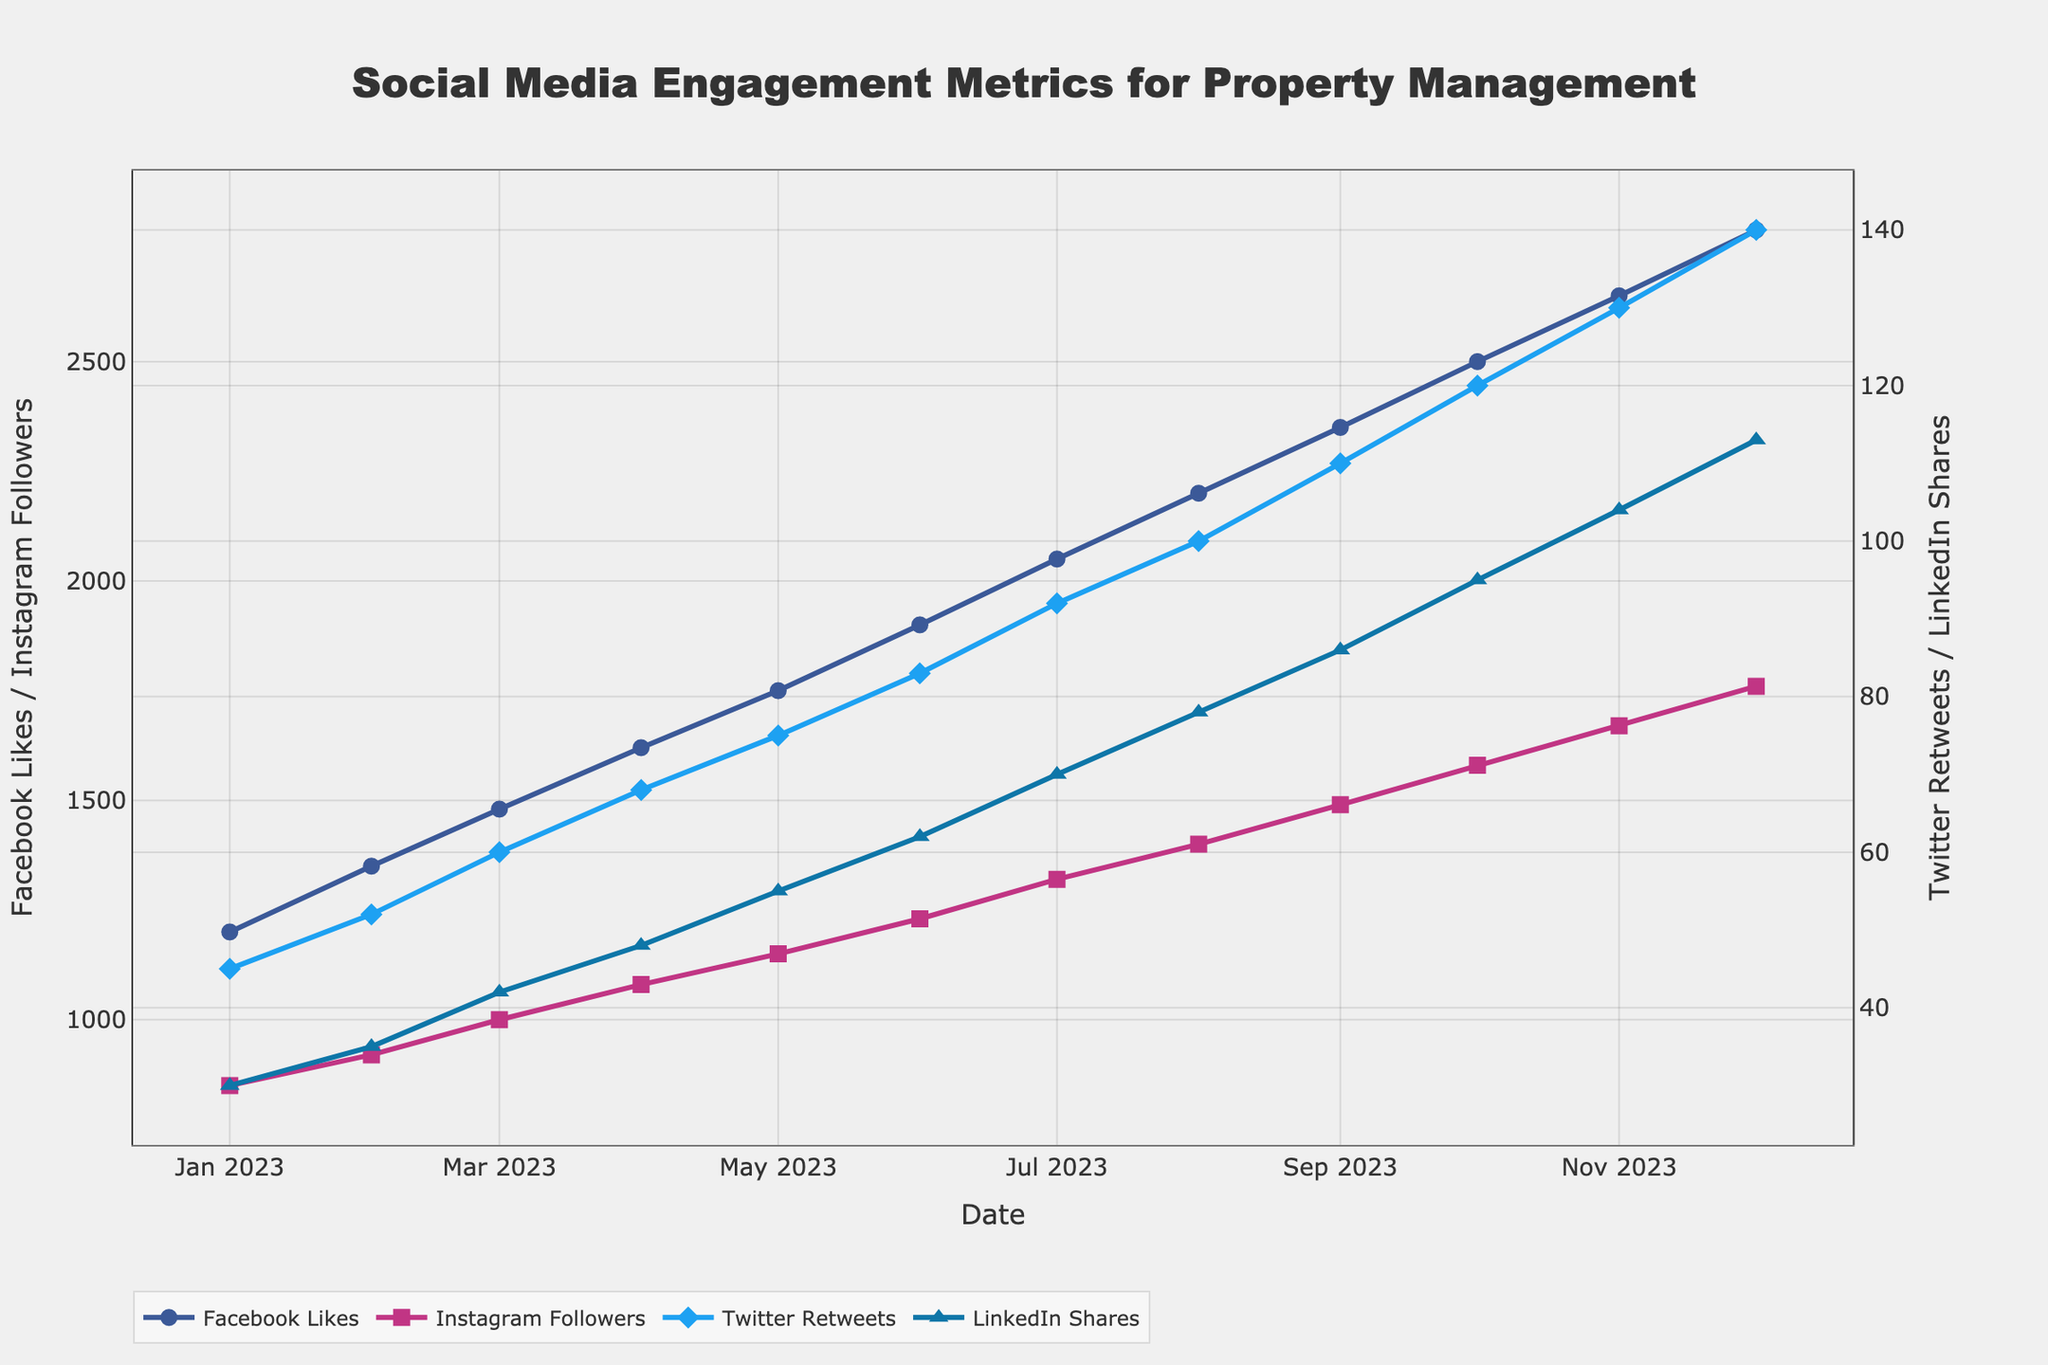What is the overall trend of Facebook Likes throughout the year? By observing the blue line representing Facebook Likes from January to December, the trend is clearly upward, indicating a consistent increase.
Answer: Increasing Which month had the largest increase in Instagram Followers compared to the previous month? By observing the pink line representing Instagram Followers, the largest jump appears between any two months. By examining the y-values, the biggest increase occurs between January (850) and February (920) which is an increase of 70 followers.
Answer: February What is the difference in LinkedIn Shares between January and December? The LinkedIn Shares in January are 30, and in December they are 113. The difference is computed as 113 - 30 = 83.
Answer: 83 Which month had more Twitter Retweets, June or November? Checking the visual points for Twitter Retweets, June has 83 and November has 130. Thus, November has more Twitter Retweets.
Answer: November How many more Facebook Likes were there in December compared to June? Facebook Likes in December are 2800, while in June they are 1900. The difference is 2800 - 1900 = 900.
Answer: 900 Which secondary y-axis metric shows a consistent increase each month throughout the year? Observing both the Twitter Retweets (blue diamonds) and LinkedIn Shares (blue triangles), both metrics show a consistent upward trend each month.
Answer: Both Twitter Retweets and LinkedIn Shares What is the average number of Instagram Followers in the first quarter (Jan-Mar)? Sum of Instagram Followers for Jan (850), Feb (920), and Mar (1000) is 850 + 920 + 1000 = 2770. The average is 2770 / 3 = 923.33.
Answer: 923.33 In which month did all four metrics collectively show a steep increase compared to the previous month? By checking each month's progression, a significant rise in all metrics is most noticeable in August, where all metrics show a noticeable jump from July numbers.
Answer: August Compare the growth trend between Instagram Followers and LinkedIn Shares. Which one has a steeper slope? Observing the visual lines, Instagram Followers (pink squares) have a steeper slope compared to LinkedIn Shares (blue triangles), indicating a faster growth rate for Instagram Followers.
Answer: Instagram Followers What is the total number of LinkedIn Shares by the end of June? Sum up LinkedIn Shares from January (30) to June (62): 30 + 35 + 42 + 48 + 55 + 62 = 272.
Answer: 272 